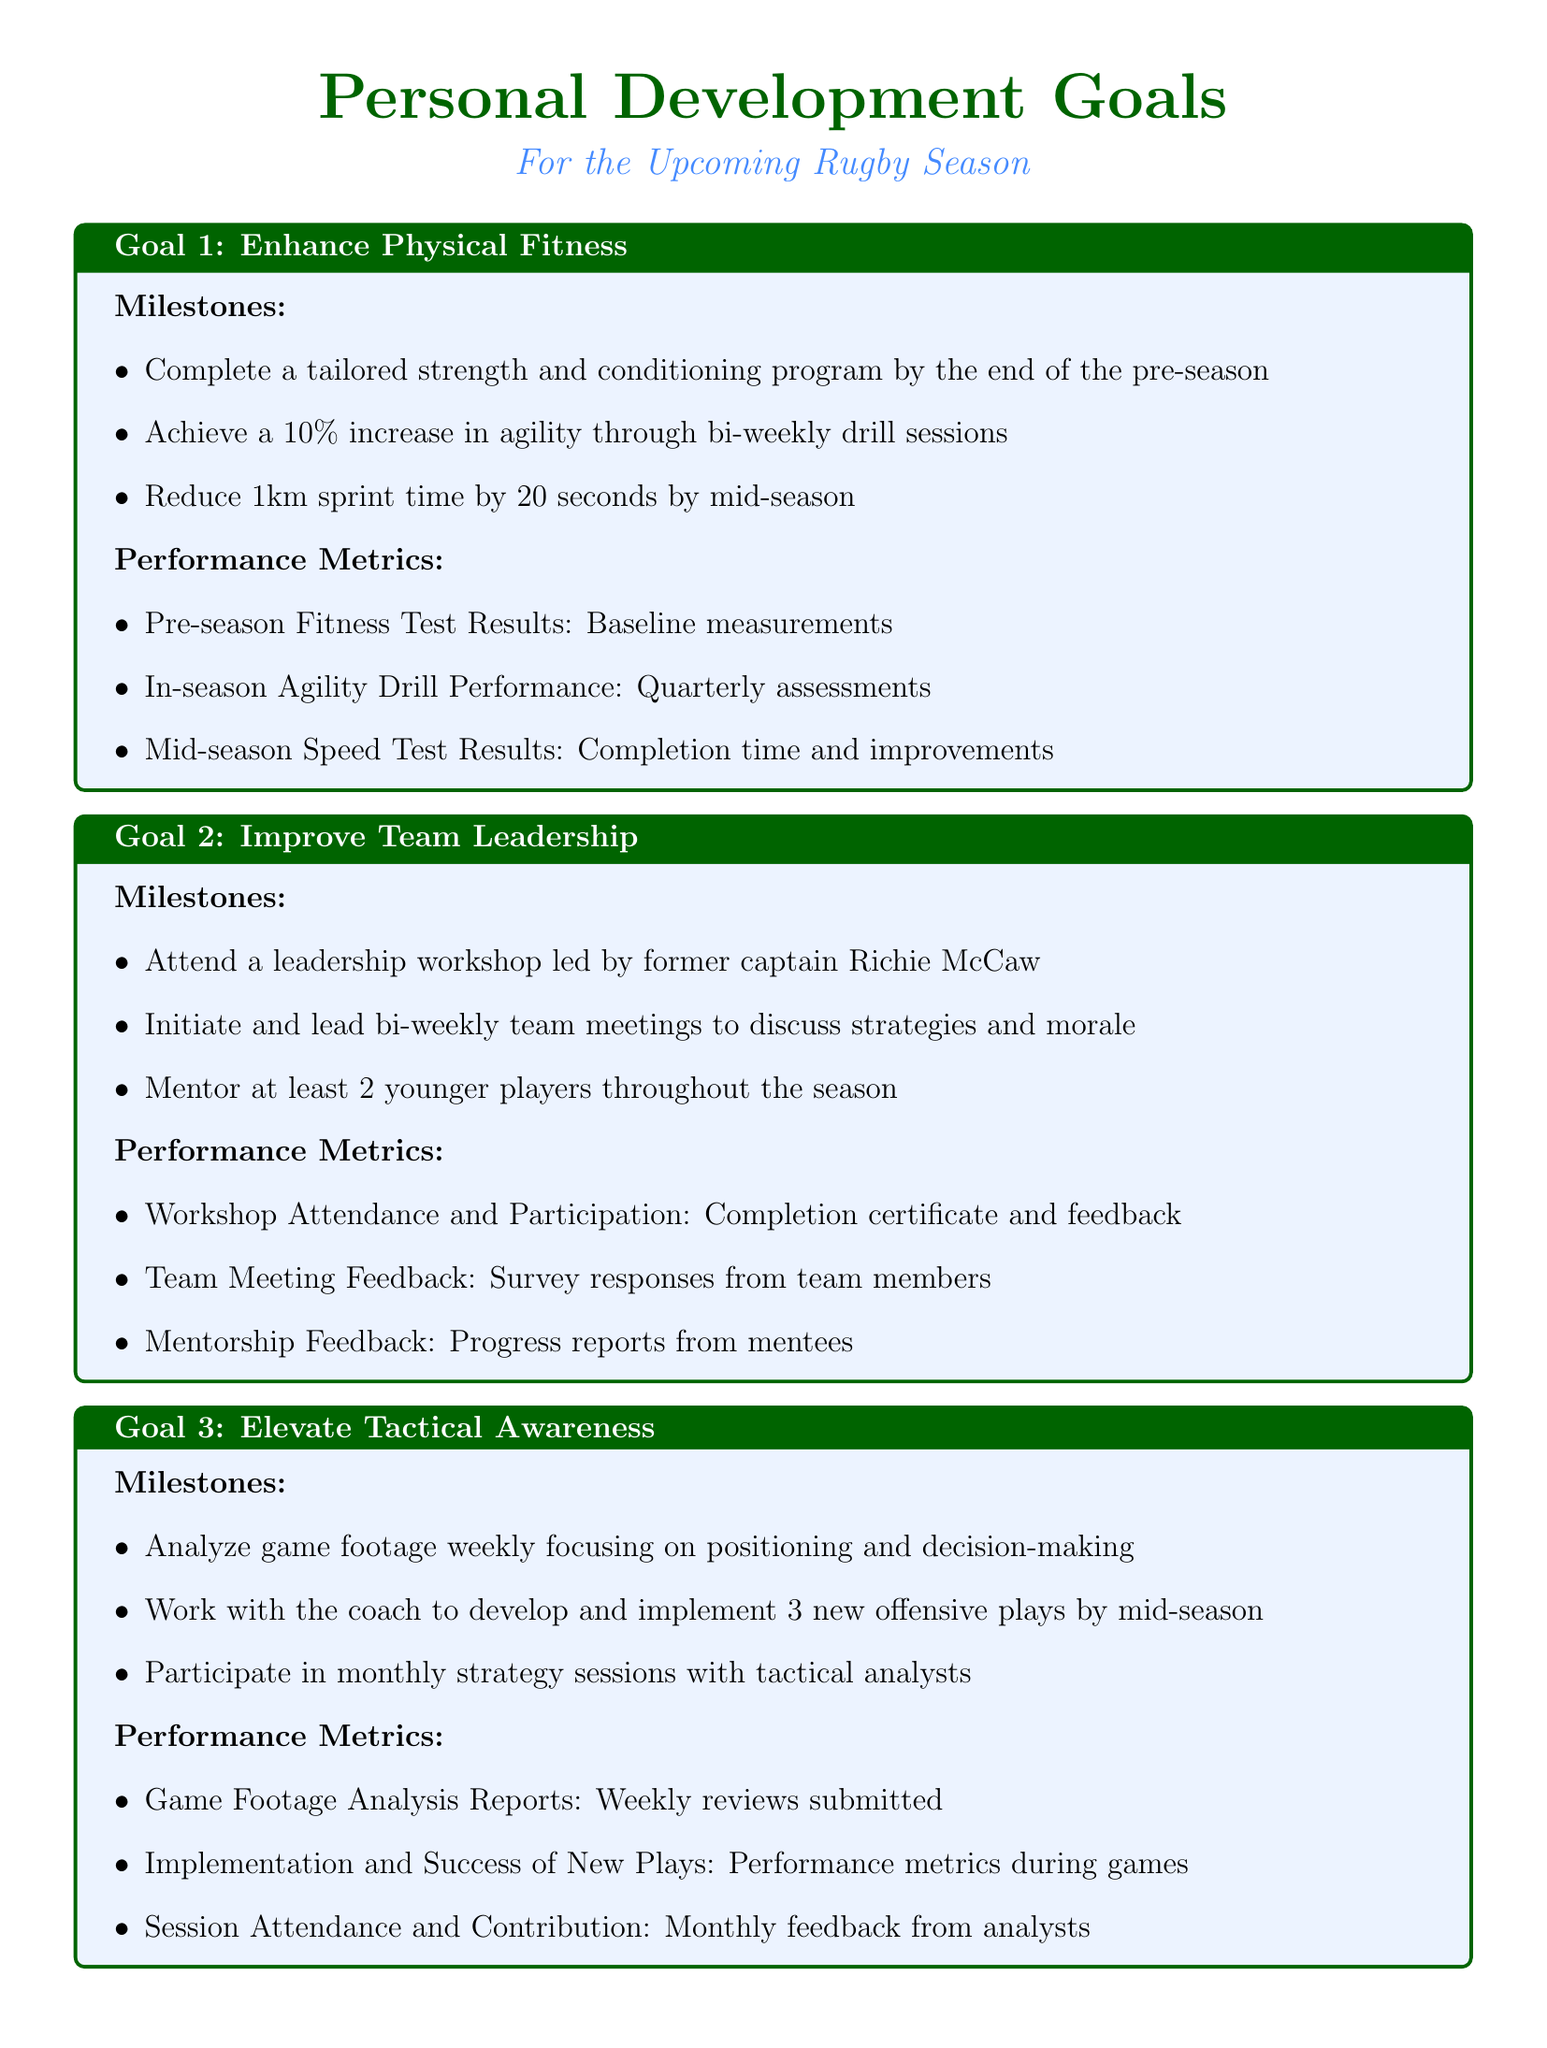What is the first personal development goal? The first personal development goal listed in the document is to enhance physical fitness.
Answer: Enhance Physical Fitness How many younger players should be mentored according to the second goal? The document states that at least 2 younger players should be mentored throughout the season.
Answer: 2 What percentage increase in agility is aimed for in the first goal? The goal sets a target of a 10% increase in agility through bi-weekly drill sessions.
Answer: 10% What workshop is suggested for developing mental toughness? A sports psychology workshop focusing on resilience is suggested for developing mental toughness.
Answer: Sports psychology workshop By what date should the tailored strength and conditioning program be completed? The program should be completed by the end of the pre-season.
Answer: End of the pre-season What is one method of evaluating team meeting effectiveness? Team meeting effectiveness is evaluated through survey responses from team members.
Answer: Survey responses What type of feedback will be collected for mentorship? Progress reports from mentees will be collected as feedback for mentorship.
Answer: Progress reports What are the performance metrics for analyzing game footage? The performance metric includes weekly reviews submitted as game footage analysis reports.
Answer: Weekly reviews submitted 